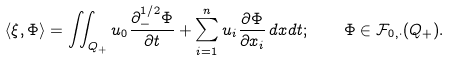<formula> <loc_0><loc_0><loc_500><loc_500>\langle \xi , \Phi \rangle = \iint _ { Q _ { + } } u _ { 0 } \frac { \partial ^ { 1 / 2 } _ { - } \Phi } { \partial t } + \sum _ { i = 1 } ^ { n } u _ { i } \frac { \partial \Phi } { \partial x _ { i } } \, d x d t ; \quad \Phi \in \mathcal { F } _ { 0 , \cdot } ( Q _ { + } ) .</formula> 